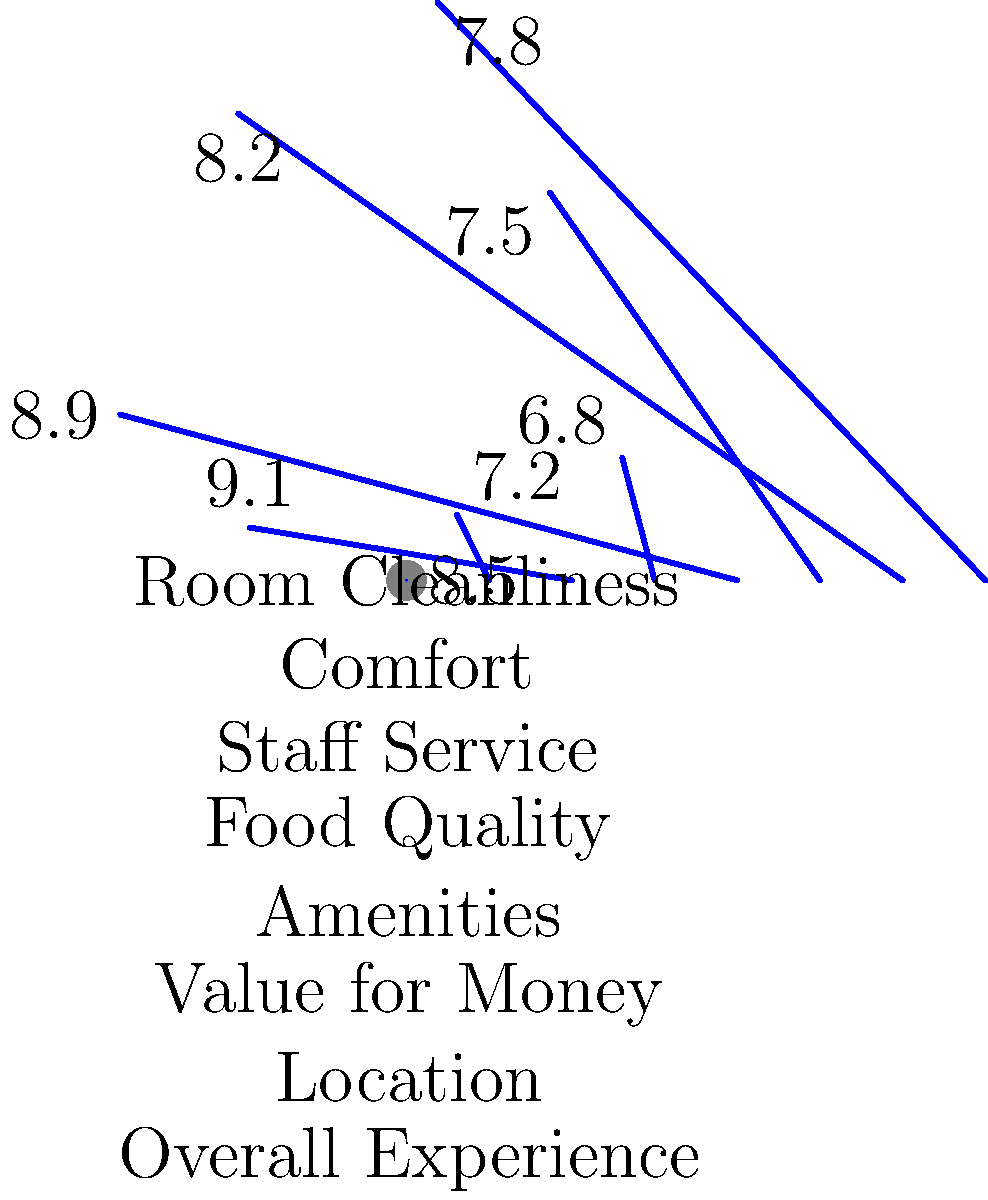Based on the polar area chart showing customer satisfaction scores for various hotel amenities, which two aspects of the hotel experience have the highest satisfaction scores, and what is their combined score? To answer this question, we need to follow these steps:

1. Identify the two highest satisfaction scores from the polar area chart:
   - Room Cleanliness: 8.5
   - Comfort: 7.2
   - Staff Service: 9.1
   - Food Quality: 6.8
   - Amenities: 8.9
   - Value for Money: 7.5
   - Location: 8.2
   - Overall Experience: 7.8

2. The two highest scores are:
   - Staff Service: 9.1
   - Amenities: 8.9

3. Calculate the combined score:
   $9.1 + 8.9 = 18.0$

Therefore, the two aspects with the highest satisfaction scores are Staff Service and Amenities, with a combined score of 18.0.
Answer: Staff Service and Amenities; 18.0 